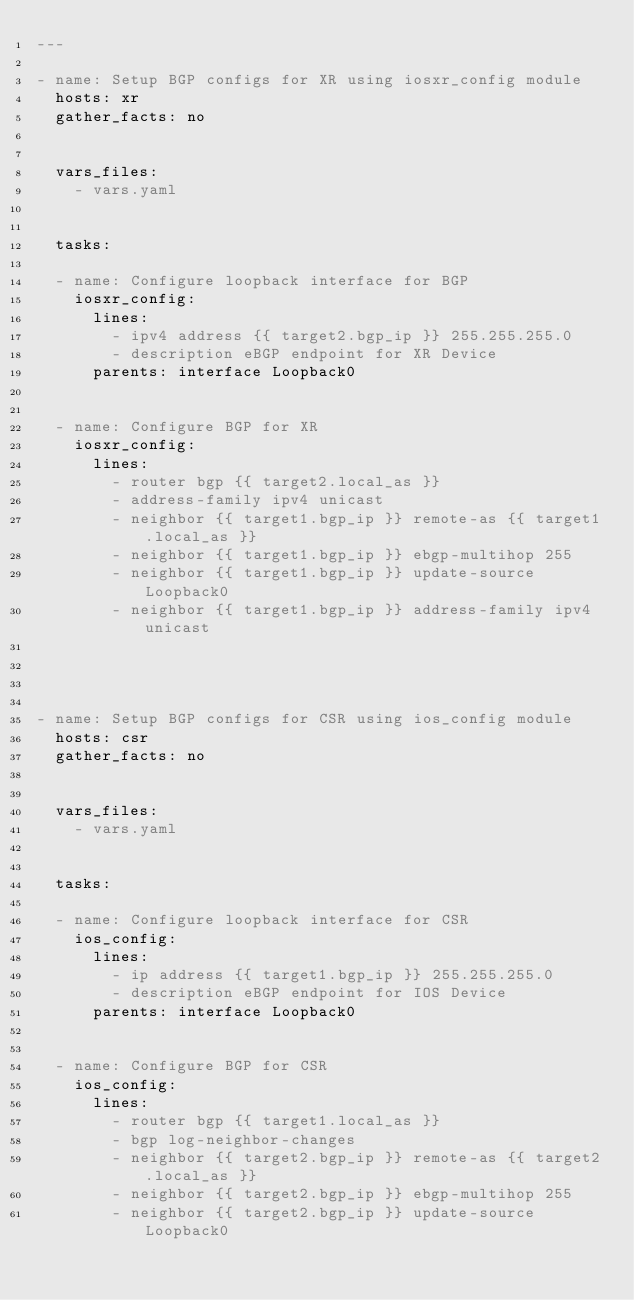<code> <loc_0><loc_0><loc_500><loc_500><_YAML_>---

- name: Setup BGP configs for XR using iosxr_config module
  hosts: xr
  gather_facts: no


  vars_files:
    - vars.yaml


  tasks:

  - name: Configure loopback interface for BGP
    iosxr_config:
      lines:
        - ipv4 address {{ target2.bgp_ip }} 255.255.255.0
        - description eBGP endpoint for XR Device
      parents: interface Loopback0


  - name: Configure BGP for XR
    iosxr_config:
      lines:
        - router bgp {{ target2.local_as }}
        - address-family ipv4 unicast
        - neighbor {{ target1.bgp_ip }} remote-as {{ target1.local_as }}
        - neighbor {{ target1.bgp_ip }} ebgp-multihop 255
        - neighbor {{ target1.bgp_ip }} update-source Loopback0
        - neighbor {{ target1.bgp_ip }} address-family ipv4 unicast




- name: Setup BGP configs for CSR using ios_config module
  hosts: csr
  gather_facts: no


  vars_files:
    - vars.yaml


  tasks:

  - name: Configure loopback interface for CSR
    ios_config:
      lines:
        - ip address {{ target1.bgp_ip }} 255.255.255.0
        - description eBGP endpoint for IOS Device
      parents: interface Loopback0


  - name: Configure BGP for CSR
    ios_config:
      lines:
        - router bgp {{ target1.local_as }}
        - bgp log-neighbor-changes
        - neighbor {{ target2.bgp_ip }} remote-as {{ target2.local_as }}
        - neighbor {{ target2.bgp_ip }} ebgp-multihop 255
        - neighbor {{ target2.bgp_ip }} update-source Loopback0

</code> 